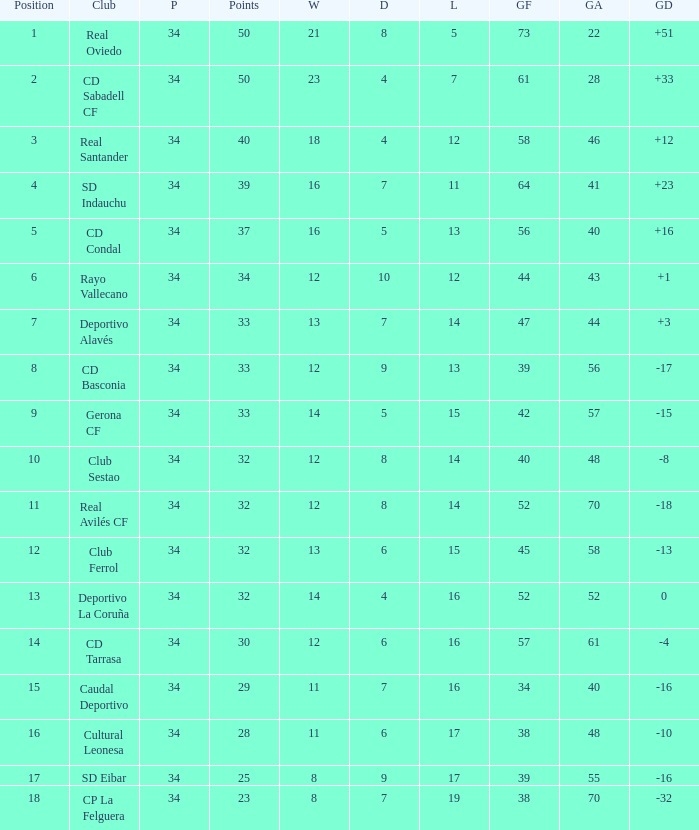Which Losses have a Goal Difference of -16, and less than 8 wins? None. 